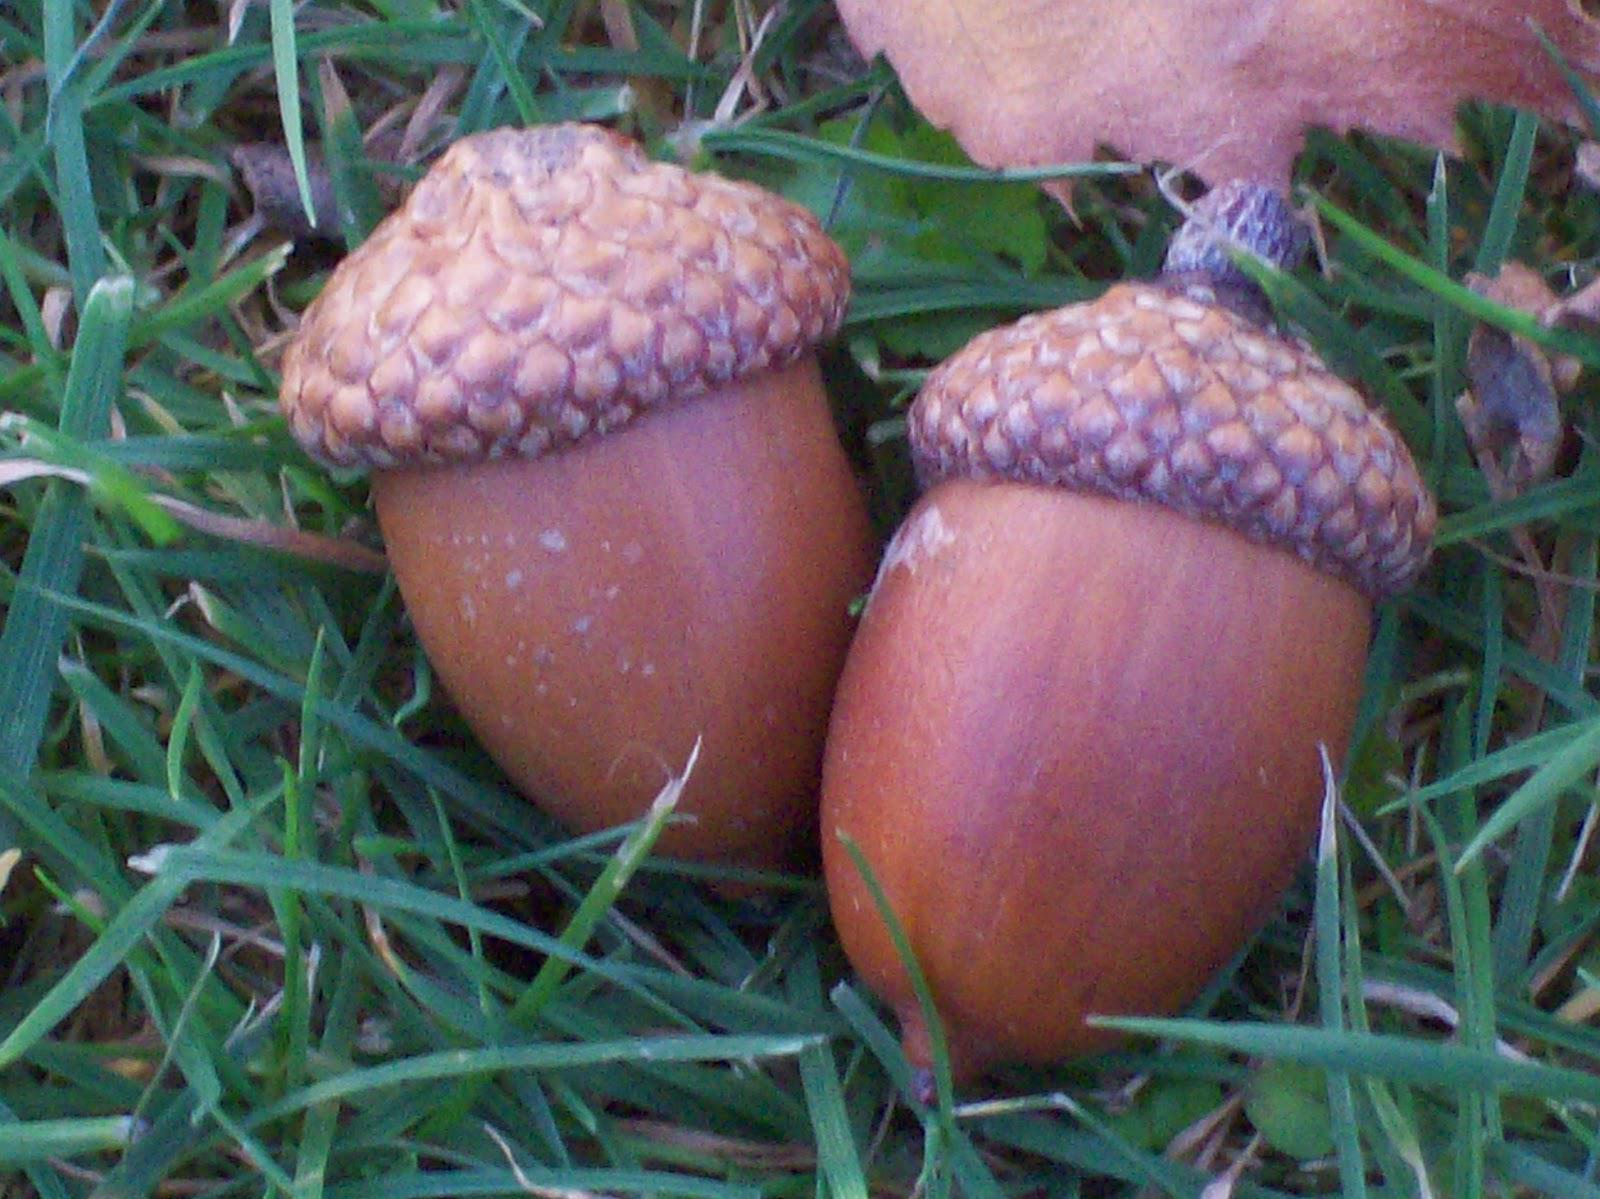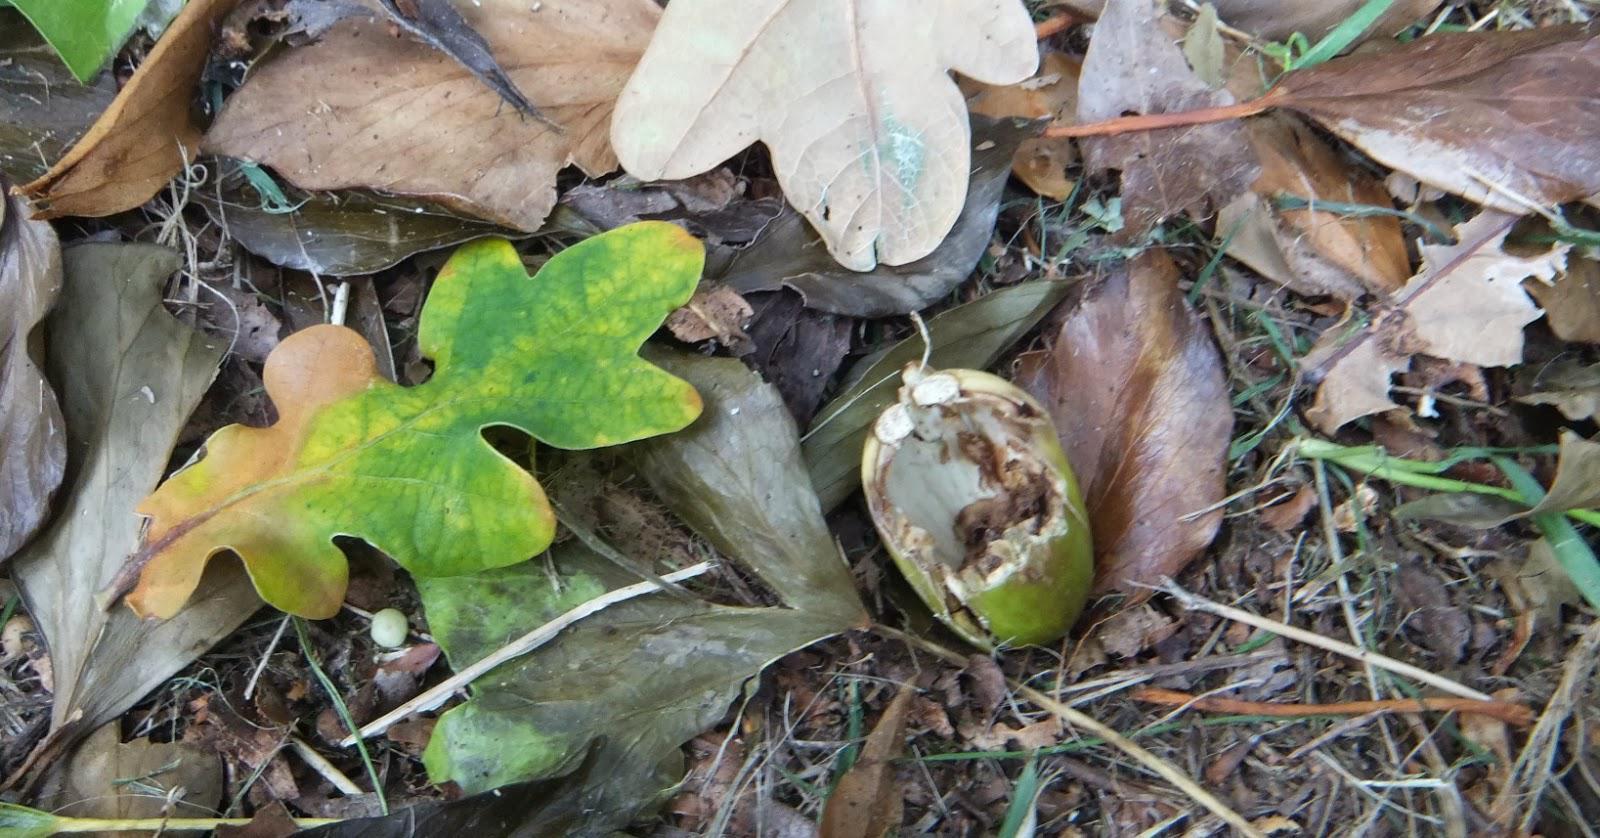The first image is the image on the left, the second image is the image on the right. Assess this claim about the two images: "In at least one  image there is a cracked acorn sitting on dirt and leaves on the ground.". Correct or not? Answer yes or no. Yes. The first image is the image on the left, the second image is the image on the right. Analyze the images presented: Is the assertion "The acorns are lying on the ground." valid? Answer yes or no. Yes. 